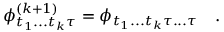Convert formula to latex. <formula><loc_0><loc_0><loc_500><loc_500>\phi _ { t _ { 1 } \dots t _ { k } \tau } ^ { ( k + 1 ) } = \phi _ { t _ { 1 } \dots t _ { k } \tau \dots \tau } \quad .</formula> 